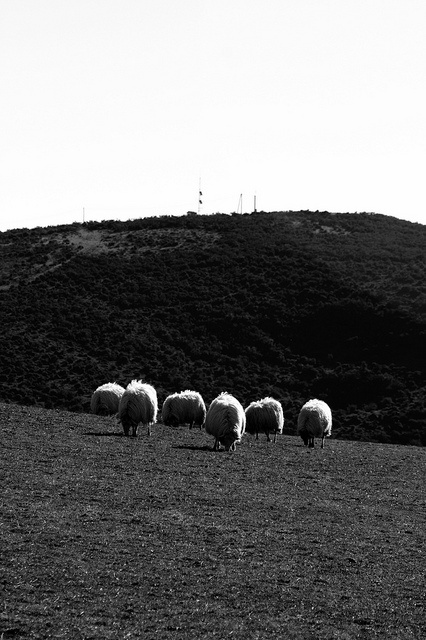Describe the objects in this image and their specific colors. I can see sheep in whitesmoke, black, white, gray, and darkgray tones, sheep in whitesmoke, black, white, gray, and darkgray tones, sheep in whitesmoke, black, white, gray, and darkgray tones, sheep in whitesmoke, black, lightgray, gray, and darkgray tones, and sheep in whitesmoke, black, white, gray, and darkgray tones in this image. 